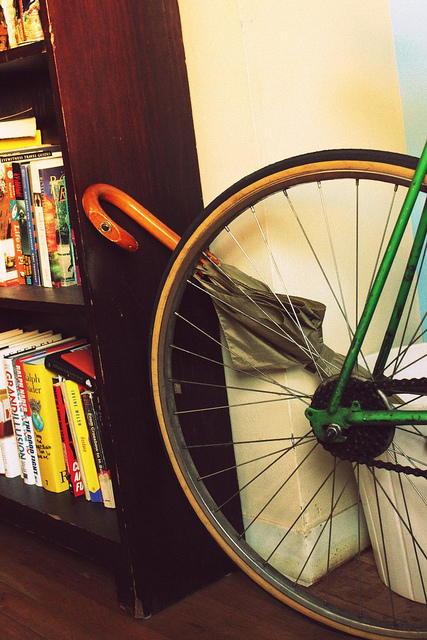Can you tell me more about the bike wheel in the image? Certainly! The image features a bicycle wheel resting against a bookshelf. It has a green frame, silver spokes, and a tan-colored tire that seems to be in good condition. This suggests the bike may be used both for transport as well as a unique decorative piece in this space. 